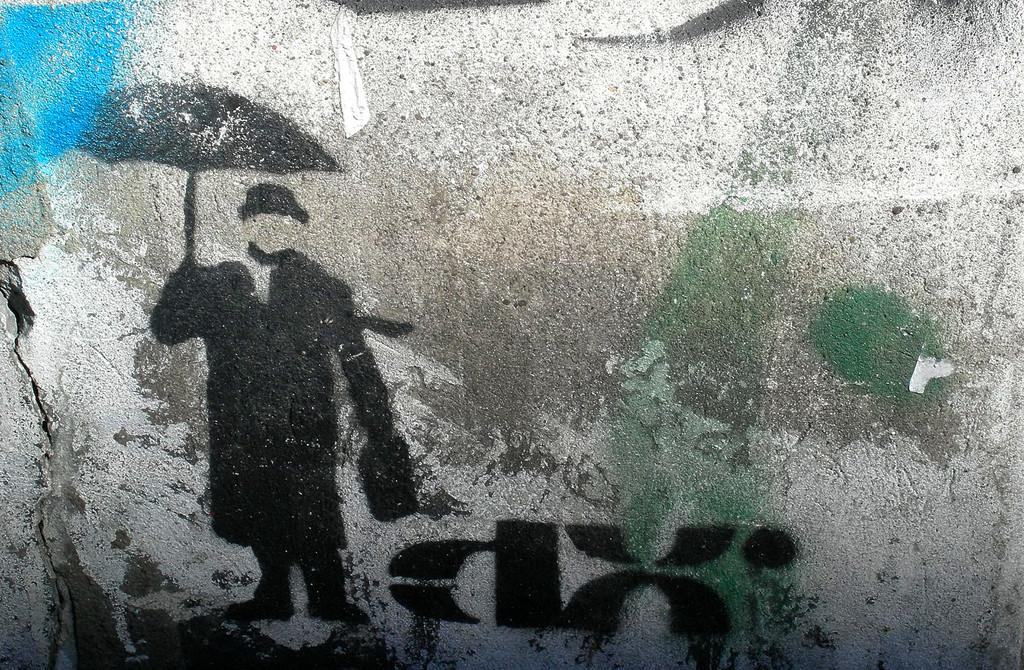What can be seen on the wall in the image? There is a painting on the wall in the image. What is the subject of the painting? The painting depicts a person. What is the person in the painting holding? The person in the painting is holding an umbrella. How many wounds can be seen on the person in the painting? There are no visible wounds on the person in the painting; they are holding an umbrella. 